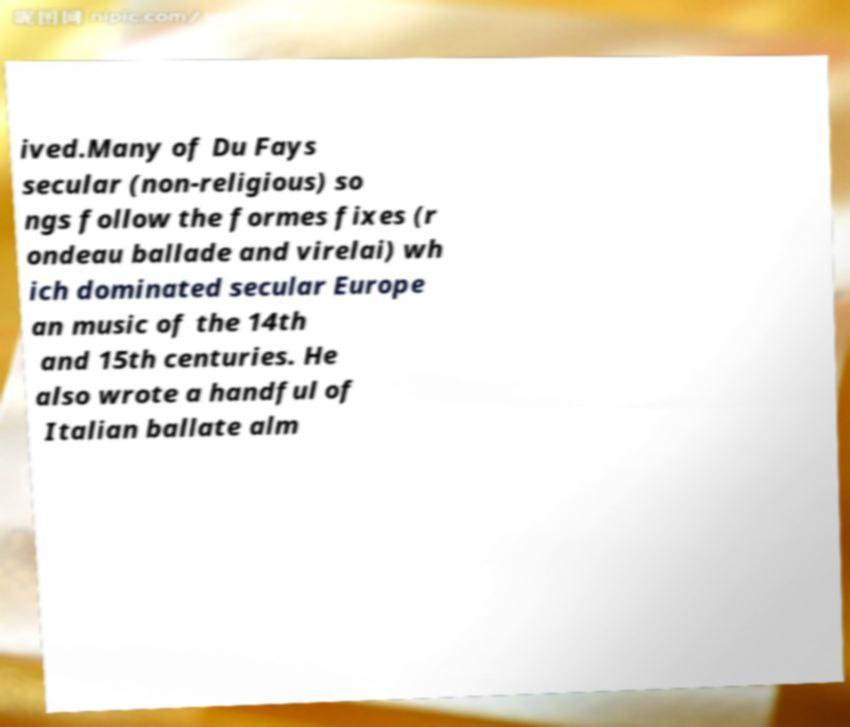I need the written content from this picture converted into text. Can you do that? ived.Many of Du Fays secular (non-religious) so ngs follow the formes fixes (r ondeau ballade and virelai) wh ich dominated secular Europe an music of the 14th and 15th centuries. He also wrote a handful of Italian ballate alm 